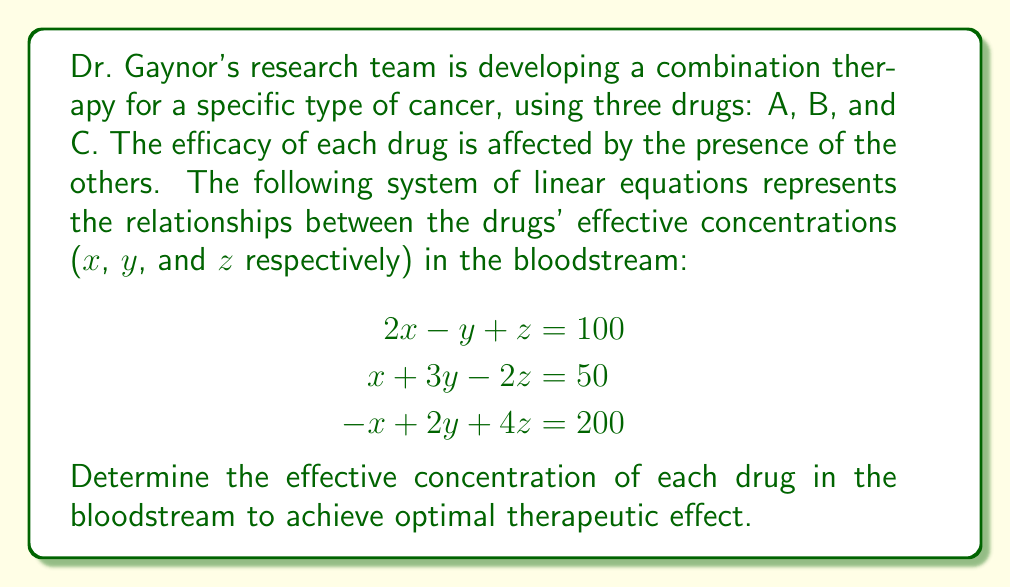Provide a solution to this math problem. To solve this system of linear equations, we'll use the Gaussian elimination method:

1) First, write the augmented matrix:

$$\begin{bmatrix}
2 & -1 & 1 & 100 \\
1 & 3 & -2 & 50 \\
-1 & 2 & 4 & 200
\end{bmatrix}$$

2) Eliminate x from the second and third rows:
   Multiply R1 by -1/2 and add to R2
   Multiply R1 by 1/2 and add to R3

$$\begin{bmatrix}
2 & -1 & 1 & 100 \\
0 & 3.5 & -2.5 & 0 \\
0 & 1.5 & 4.5 & 250
\end{bmatrix}$$

3) Eliminate y from the third row:
   Multiply R2 by -3/7 and add to R3

$$\begin{bmatrix}
2 & -1 & 1 & 100 \\
0 & 3.5 & -2.5 & 0 \\
0 & 0 & 5.5714 & 250
\end{bmatrix}$$

4) Back-substitute to find z:
   $5.5714z = 250$
   $z = 44.8718$

5) Substitute z in R2 to find y:
   $3.5y - 2.5(44.8718) = 0$
   $3.5y = 112.1795$
   $y = 32.0513$

6) Substitute y and z in R1 to find x:
   $2x - 32.0513 + 44.8718 = 100$
   $2x = 87.1795$
   $x = 43.5897$

Therefore, the effective concentrations are:
Drug A (x) ≈ 43.59 units
Drug B (y) ≈ 32.05 units
Drug C (z) ≈ 44.87 units
Answer: The effective concentrations in the bloodstream for optimal therapeutic effect are:
Drug A: 43.59 units
Drug B: 32.05 units
Drug C: 44.87 units 